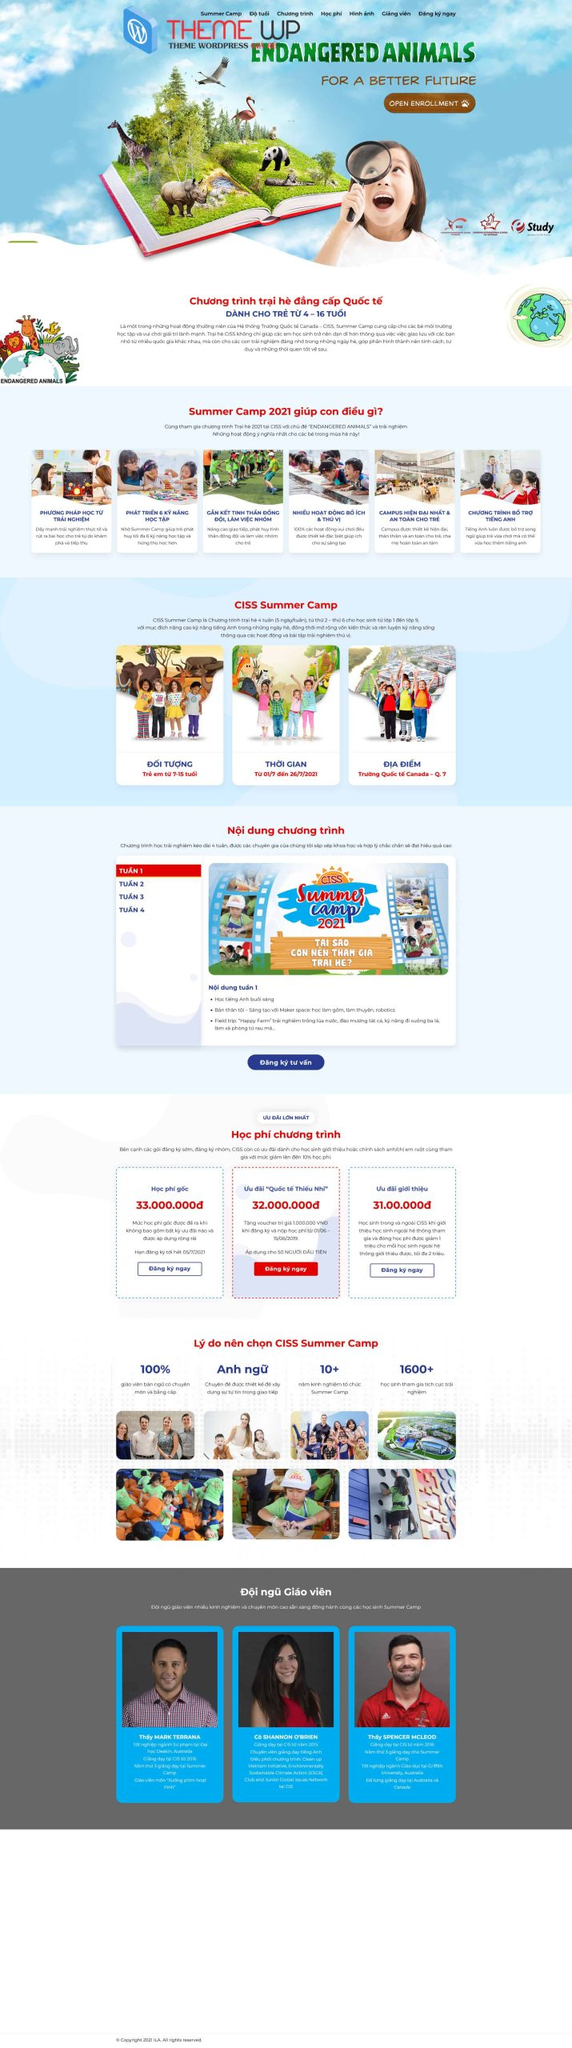Liệt kê 5 ngành nghề, lĩnh vực phù hợp với website này, phân cách các màu sắc bằng dấu phẩy. Chỉ trả về kết quả, phân cách bằng dấy phẩy
 Giáo dục, Trại hè, Bảo vệ động vật, Môi trường, Hoạt động ngoại khóa 